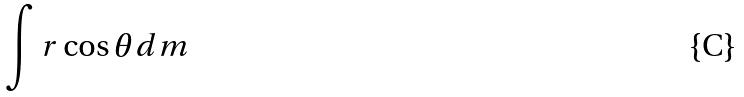<formula> <loc_0><loc_0><loc_500><loc_500>\int r \cos \theta d m</formula> 